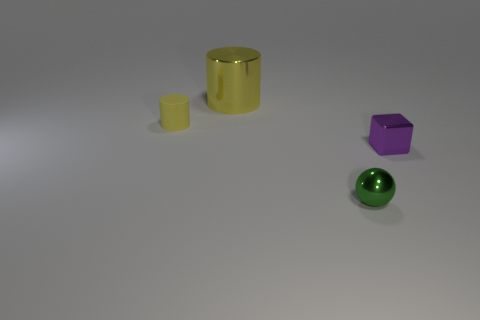What is the tiny thing behind the purple metal cube made of?
Keep it short and to the point. Rubber. There is a object right of the small metallic object left of the tiny shiny thing right of the tiny green thing; what is its shape?
Your answer should be very brief. Cube. Do the small metallic sphere that is in front of the small purple shiny cube and the small object that is on the left side of the large cylinder have the same color?
Offer a terse response. No. Is the number of big yellow cylinders right of the large yellow shiny thing less than the number of green spheres that are on the right side of the matte object?
Keep it short and to the point. Yes. Is there any other thing that is the same shape as the tiny yellow matte object?
Give a very brief answer. Yes. Is the shape of the rubber object the same as the object on the right side of the metal sphere?
Offer a very short reply. No. What number of things are yellow objects that are behind the small matte cylinder or metallic objects that are behind the purple metal block?
Make the answer very short. 1. What is the material of the small green thing?
Keep it short and to the point. Metal. What number of other things are the same size as the metallic cylinder?
Provide a short and direct response. 0. There is a green object that is left of the tiny purple metallic object; what size is it?
Your answer should be very brief. Small. 